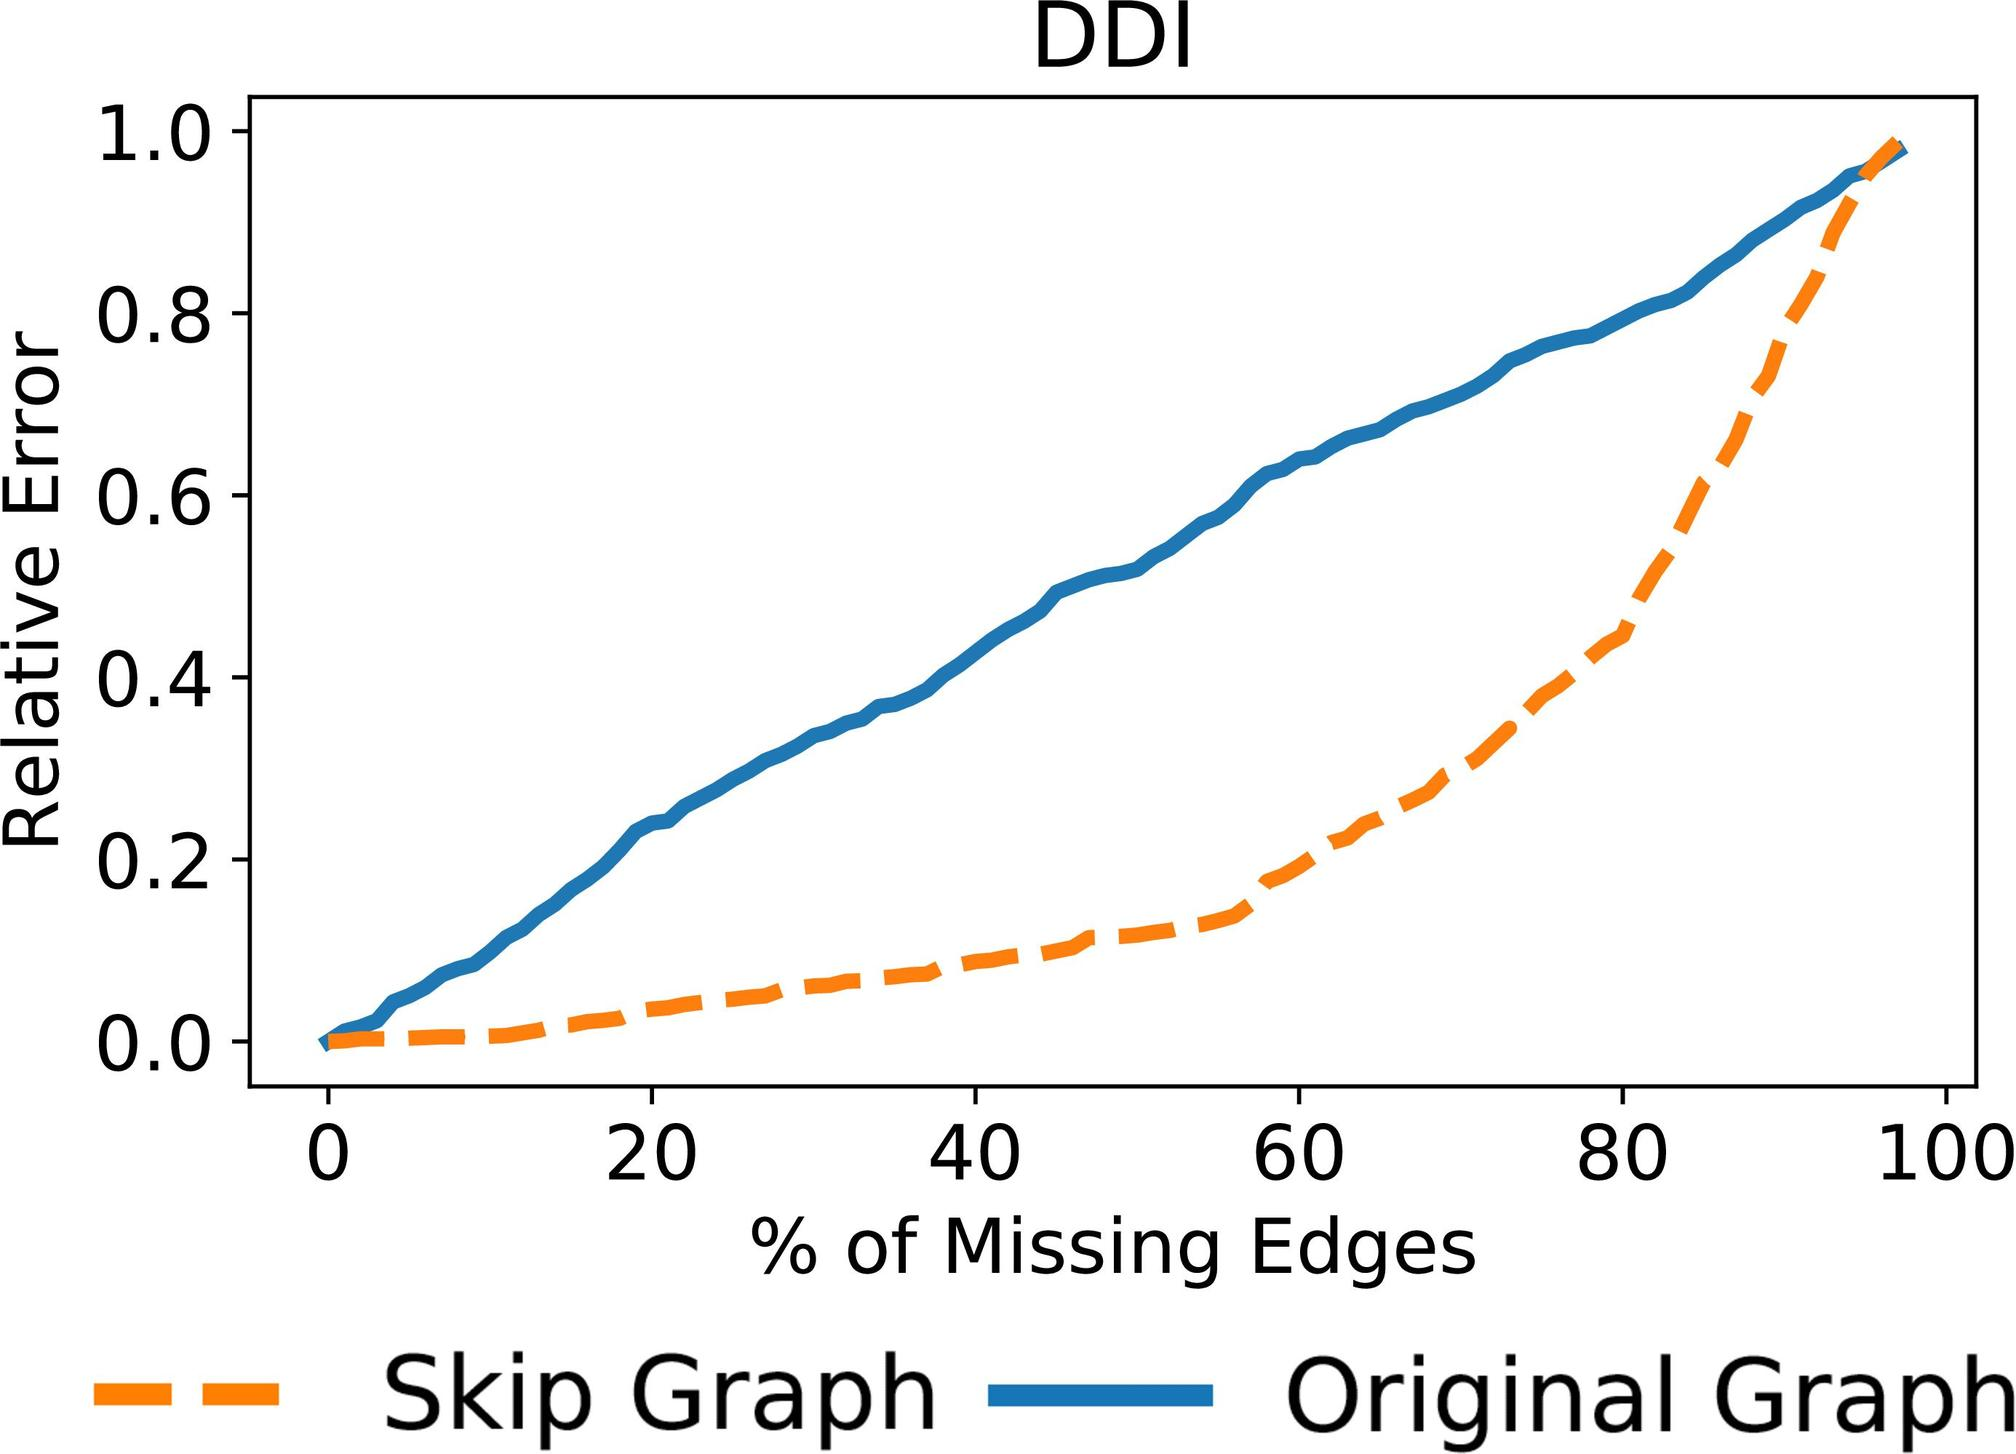Based on the graph, how does the relative error change as the percentage of missing edges increases for the Skip Graph? A. It decreases steadily. B. It remains constant. C. It increases steadily. D. It increases and then decreases. The dashed orange line representing the Skip Graph in the graph shows a steady increase in relative error as the percentage of missing edges increases. Therefore, the correct answer is C. 